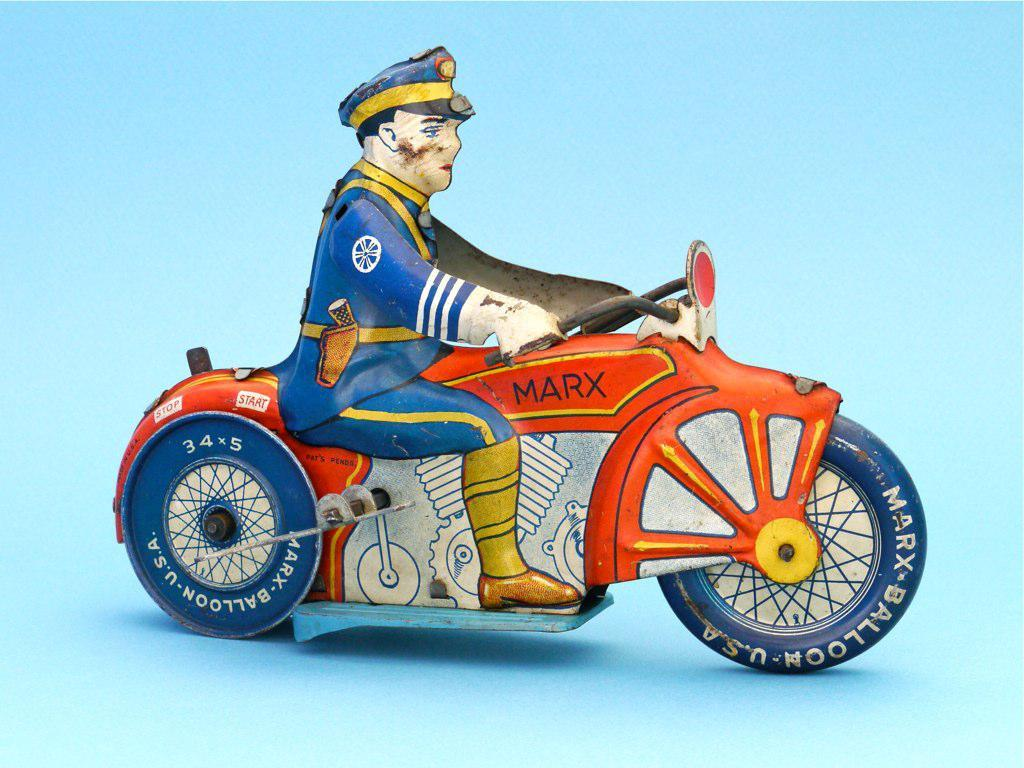What is the main subject of the image? There is an art piece in the image. What side of the art piece is shown laughing in the image? There is no side of the art piece shown laughing in the image, as it is not a living being capable of laughter. 